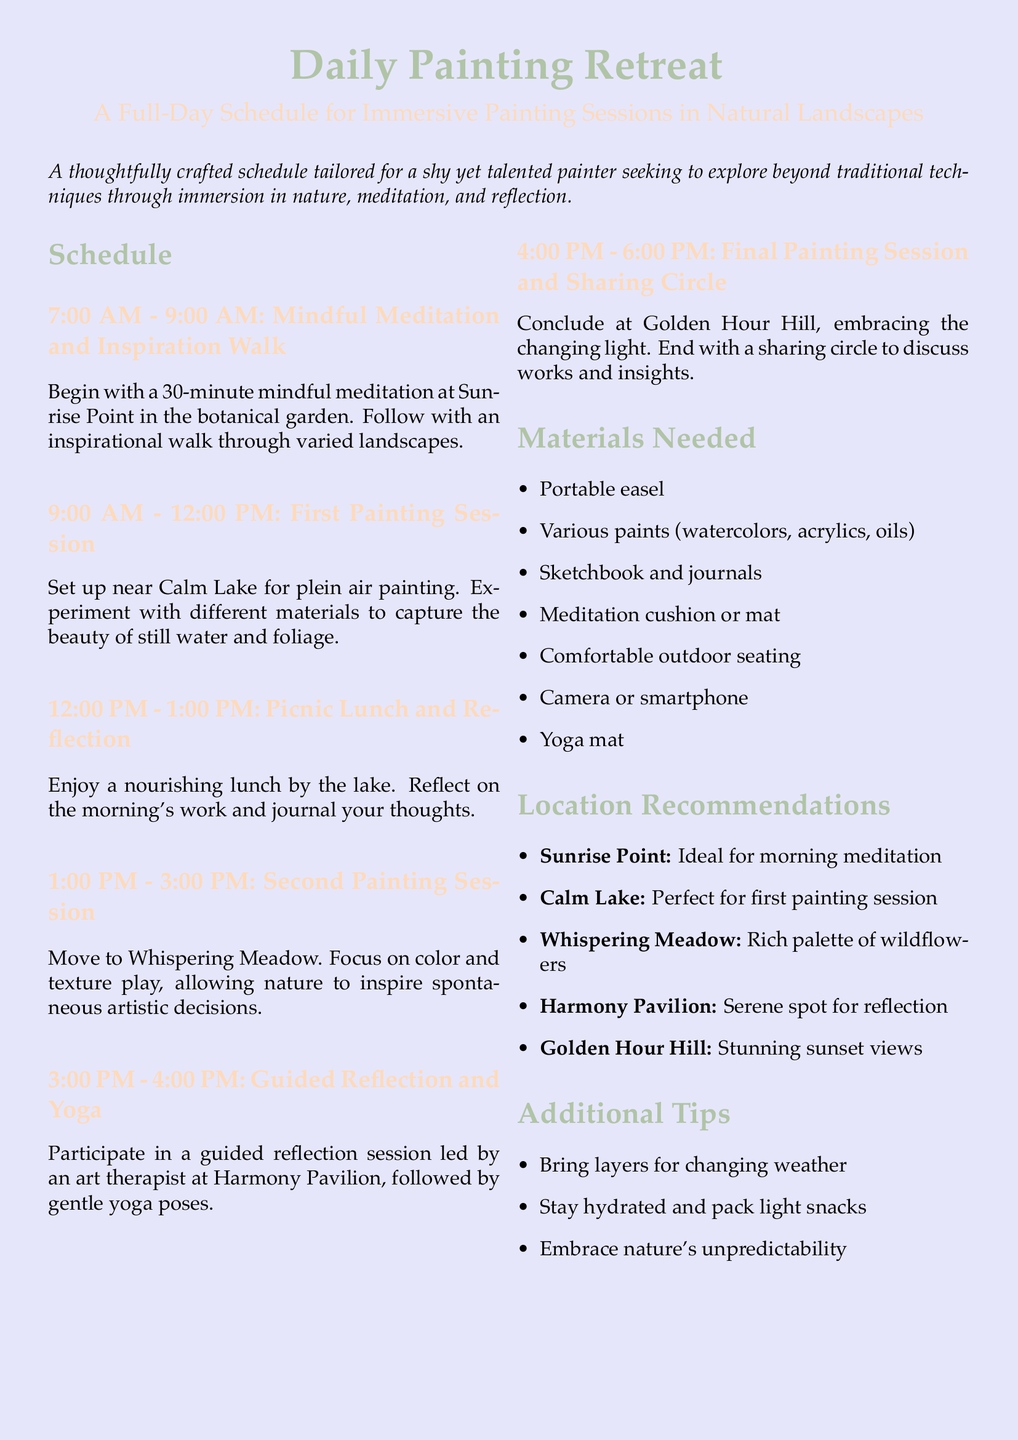What time does the painting retreat begin? The painting retreat starts at 7:00 AM.
Answer: 7:00 AM What is the location for the first painting session? The first painting session takes place near Calm Lake.
Answer: Calm Lake How long is the picnic lunch and reflection period? The picnic lunch and reflection period lasts for 1 hour.
Answer: 1 hour What is the focus of the second painting session? The focus of the second painting session is on color and texture play.
Answer: Color and texture play What materials are needed for the painting retreat? The document lists several materials, including a portable easel and various paints.
Answer: Portable easel, various paints What is the purpose of the sharing circle? The sharing circle is meant to discuss works and insights from the day's activities.
Answer: Discuss works and insights What type of session follows the second painting session? A guided reflection and yoga session follows the second painting session.
Answer: Guided reflection and yoga Where is the meditation session taking place? The meditation session takes place at Sunrise Point.
Answer: Sunrise Point What should participants bring for the weather? Participants should bring layers for changing weather.
Answer: Layers for changing weather 